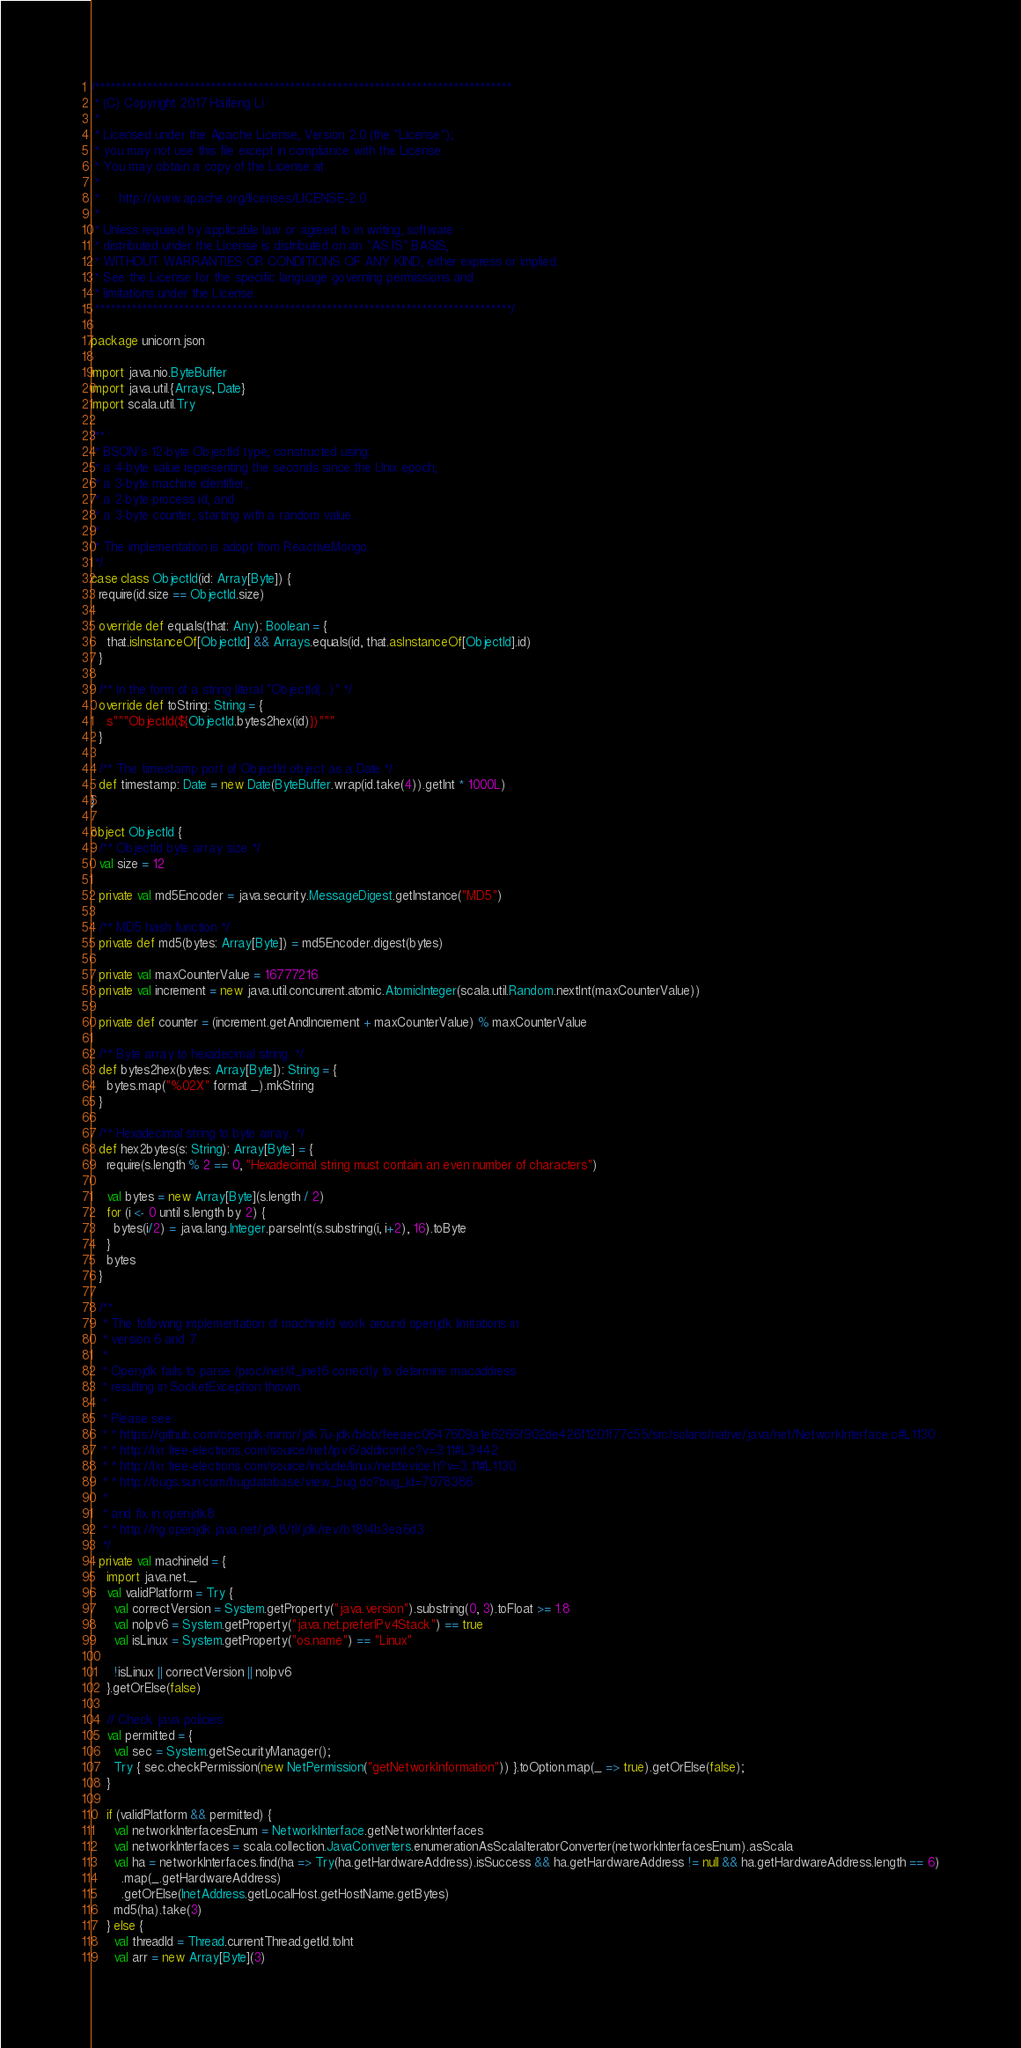Convert code to text. <code><loc_0><loc_0><loc_500><loc_500><_Scala_>/*******************************************************************************
 * (C) Copyright 2017 Haifeng Li
 *   
 * Licensed under the Apache License, Version 2.0 (the "License");
 * you may not use this file except in compliance with the License.
 * You may obtain a copy of the License at
 *  
 *     http://www.apache.org/licenses/LICENSE-2.0
 *
 * Unless required by applicable law or agreed to in writing, software
 * distributed under the License is distributed on an "AS IS" BASIS,
 * WITHOUT WARRANTIES OR CONDITIONS OF ANY KIND, either express or implied.
 * See the License for the specific language governing permissions and
 * limitations under the License.
 *******************************************************************************/

package unicorn.json

import java.nio.ByteBuffer
import java.util.{Arrays, Date}
import scala.util.Try

/**
 * BSON's 12-byte ObjectId type, constructed using:
 * a 4-byte value representing the seconds since the Unix epoch,
 * a 3-byte machine identifier,
 * a 2-byte process id, and
 * a 3-byte counter, starting with a random value.
 *
 * The implementation is adopt from ReactiveMongo.
 */
case class ObjectId(id: Array[Byte]) {
  require(id.size == ObjectId.size)

  override def equals(that: Any): Boolean = {
    that.isInstanceOf[ObjectId] && Arrays.equals(id, that.asInstanceOf[ObjectId].id)
  }

  /** In the form of a string literal "ObjectId(...)" */
  override def toString: String = {
    s"""ObjectId(${ObjectId.bytes2hex(id)})"""
  }

  /** The timestamp port of ObjectId object as a Date */
  def timestamp: Date = new Date(ByteBuffer.wrap(id.take(4)).getInt * 1000L)
}

object ObjectId {
  /** ObjectId byte array size */
  val size = 12

  private val md5Encoder = java.security.MessageDigest.getInstance("MD5")

  /** MD5 hash function */
  private def md5(bytes: Array[Byte]) = md5Encoder.digest(bytes)

  private val maxCounterValue = 16777216
  private val increment = new java.util.concurrent.atomic.AtomicInteger(scala.util.Random.nextInt(maxCounterValue))

  private def counter = (increment.getAndIncrement + maxCounterValue) % maxCounterValue

  /** Byte array to hexadecimal string. */
  def bytes2hex(bytes: Array[Byte]): String = {
    bytes.map("%02X" format _).mkString
  }

  /** Hexadecimal string to byte array. */
  def hex2bytes(s: String): Array[Byte] = {
    require(s.length % 2 == 0, "Hexadecimal string must contain an even number of characters")

    val bytes = new Array[Byte](s.length / 2)
    for (i <- 0 until s.length by 2) {
      bytes(i/2) = java.lang.Integer.parseInt(s.substring(i, i+2), 16).toByte
    }
    bytes
  }

  /**
   * The following implementation of machineId work around openjdk limitations in
   * version 6 and 7
   *
   * Openjdk fails to parse /proc/net/if_inet6 correctly to determine macaddress
   * resulting in SocketException thrown.
   *
   * Please see:
   * * https://github.com/openjdk-mirror/jdk7u-jdk/blob/feeaec0647609a1e6266f902de426f1201f77c55/src/solaris/native/java/net/NetworkInterface.c#L1130
   * * http://lxr.free-electrons.com/source/net/ipv6/addrconf.c?v=3.11#L3442
   * * http://lxr.free-electrons.com/source/include/linux/netdevice.h?v=3.11#L1130
   * * http://bugs.sun.com/bugdatabase/view_bug.do?bug_id=7078386
   *
   * and fix in openjdk8:
   * * http://hg.openjdk.java.net/jdk8/tl/jdk/rev/b1814b3ea6d3
   */
  private val machineId = {
    import java.net._
    val validPlatform = Try {
      val correctVersion = System.getProperty("java.version").substring(0, 3).toFloat >= 1.8
      val noIpv6 = System.getProperty("java.net.preferIPv4Stack") == true
      val isLinux = System.getProperty("os.name") == "Linux"

      !isLinux || correctVersion || noIpv6
    }.getOrElse(false)

    // Check java policies
    val permitted = {
      val sec = System.getSecurityManager();
      Try { sec.checkPermission(new NetPermission("getNetworkInformation")) }.toOption.map(_ => true).getOrElse(false);
    }

    if (validPlatform && permitted) {
      val networkInterfacesEnum = NetworkInterface.getNetworkInterfaces
      val networkInterfaces = scala.collection.JavaConverters.enumerationAsScalaIteratorConverter(networkInterfacesEnum).asScala
      val ha = networkInterfaces.find(ha => Try(ha.getHardwareAddress).isSuccess && ha.getHardwareAddress != null && ha.getHardwareAddress.length == 6)
        .map(_.getHardwareAddress)
        .getOrElse(InetAddress.getLocalHost.getHostName.getBytes)
      md5(ha).take(3)
    } else {
      val threadId = Thread.currentThread.getId.toInt
      val arr = new Array[Byte](3)
</code> 